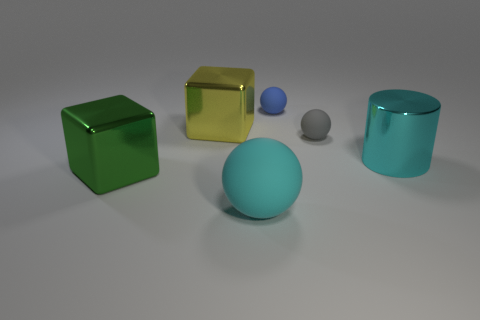Add 2 gray matte balls. How many objects exist? 8 Subtract all cubes. How many objects are left? 4 Subtract all large purple cylinders. Subtract all large green metal blocks. How many objects are left? 5 Add 6 green metallic things. How many green metallic things are left? 7 Add 1 blue spheres. How many blue spheres exist? 2 Subtract 0 cyan blocks. How many objects are left? 6 